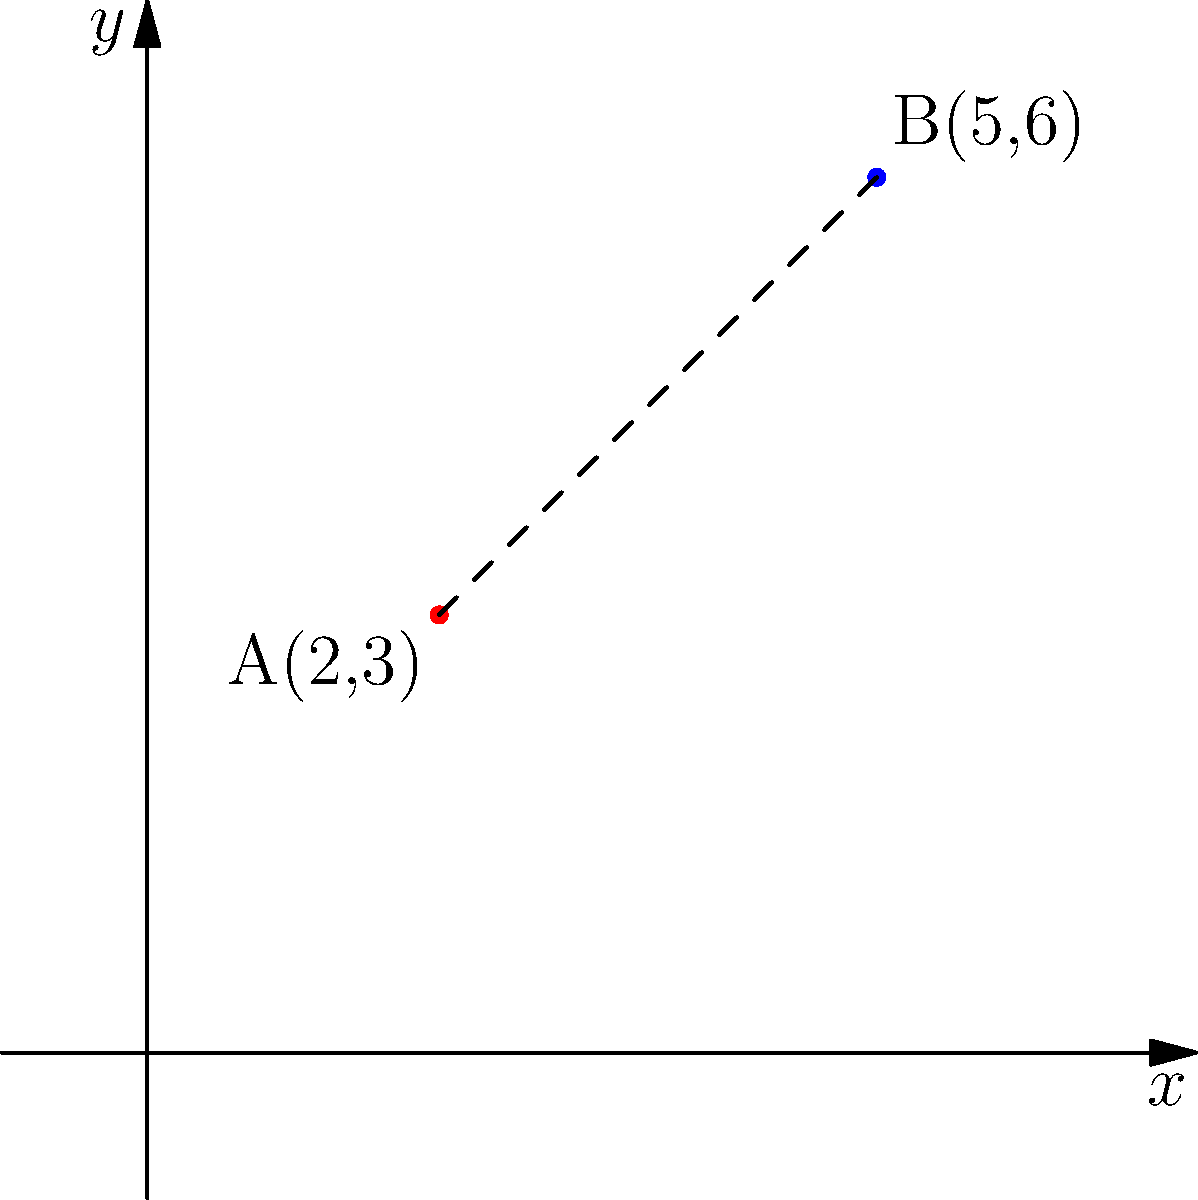In a coordinate plane, point A has coordinates (2,3) and point B has coordinates (5,6). Calculate the distance between these two points using the distance formula. Round your answer to two decimal places. To find the distance between two points, we use the distance formula:

$$d = \sqrt{(x_2 - x_1)^2 + (y_2 - y_1)^2}$$

Where $(x_1, y_1)$ are the coordinates of the first point and $(x_2, y_2)$ are the coordinates of the second point.

Step 1: Identify the coordinates
Point A: $(x_1, y_1) = (2, 3)$
Point B: $(x_2, y_2) = (5, 6)$

Step 2: Substitute the values into the formula
$$d = \sqrt{(5 - 2)^2 + (6 - 3)^2}$$

Step 3: Simplify the expressions inside the parentheses
$$d = \sqrt{3^2 + 3^2}$$

Step 4: Calculate the squares
$$d = \sqrt{9 + 9}$$

Step 5: Add the values under the square root
$$d = \sqrt{18}$$

Step 6: Simplify the square root
$$d = 3\sqrt{2} \approx 4.24$$

Step 7: Round to two decimal places
$d \approx 4.24$
Answer: 4.24 units 